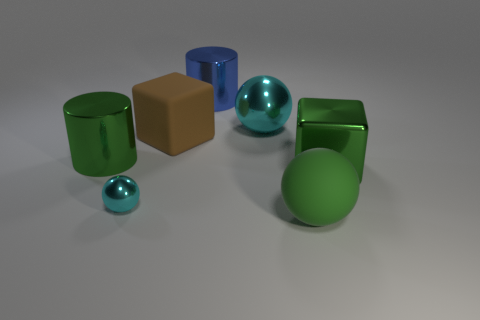What is the size of the cyan shiny object that is to the left of the blue object? The cyan shiny object appears to be quite small, especially when compared to the objects surrounding it. Its smooth, reflective surface and spherical shape indicate it's likely a small marble or a similar object. 